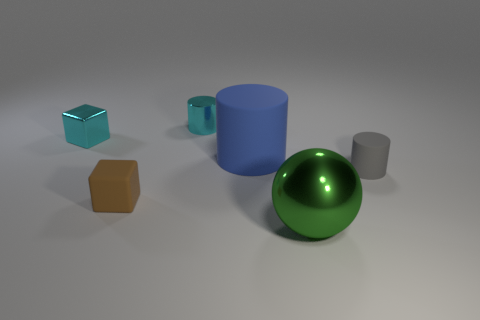Add 1 large blue matte things. How many objects exist? 7 Subtract all spheres. How many objects are left? 5 Add 6 matte blocks. How many matte blocks exist? 7 Subtract 0 purple spheres. How many objects are left? 6 Subtract all big blue rubber cylinders. Subtract all tiny metal cylinders. How many objects are left? 4 Add 6 gray objects. How many gray objects are left? 7 